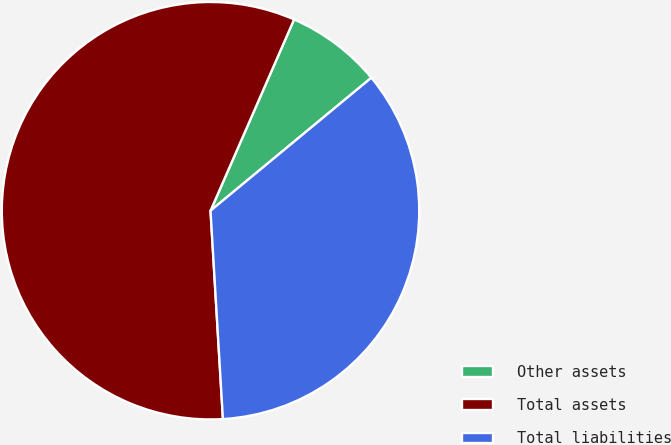Convert chart. <chart><loc_0><loc_0><loc_500><loc_500><pie_chart><fcel>Other assets<fcel>Total assets<fcel>Total liabilities<nl><fcel>7.45%<fcel>57.5%<fcel>35.05%<nl></chart> 